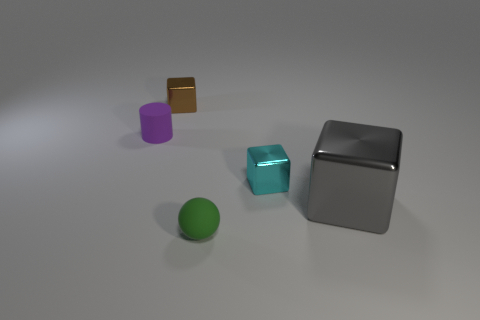What number of green spheres are in front of the cyan metallic block?
Provide a succinct answer. 1. What color is the small metallic thing behind the small cube that is to the right of the brown thing?
Provide a short and direct response. Brown. What number of other things are the same material as the tiny purple cylinder?
Offer a terse response. 1. Is the number of cubes in front of the cyan metal object the same as the number of metallic things?
Offer a very short reply. No. The object that is behind the object that is to the left of the small brown object on the left side of the cyan object is made of what material?
Your answer should be compact. Metal. The small metal thing that is left of the cyan thing is what color?
Your response must be concise. Brown. Is there anything else that is the same shape as the tiny purple rubber thing?
Provide a succinct answer. No. How big is the sphere in front of the small cyan block on the right side of the green rubber thing?
Your answer should be compact. Small. Is the number of cyan metal cubes that are on the right side of the tiny green rubber object the same as the number of tiny cyan things that are in front of the large metal thing?
Your response must be concise. No. Is there any other thing that is the same size as the gray metal thing?
Offer a terse response. No. 